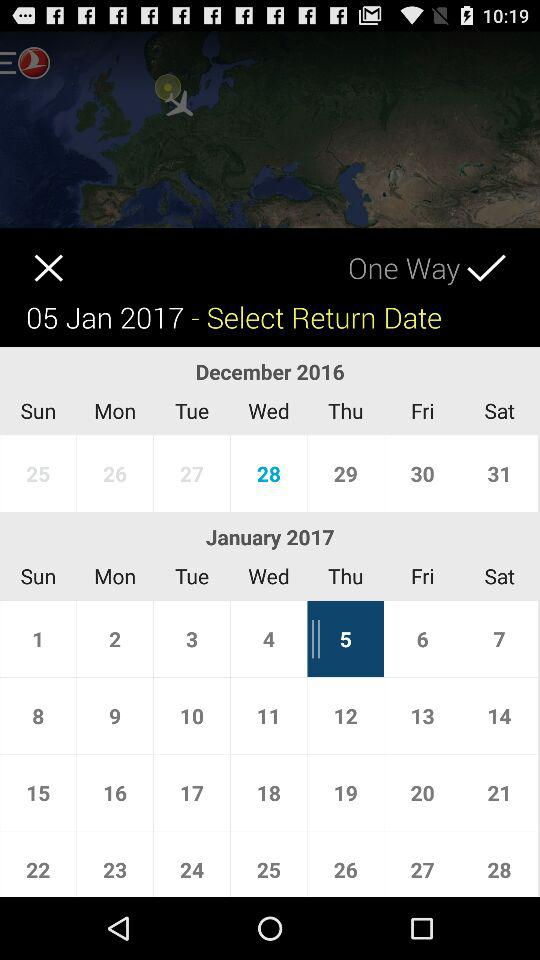Is this one way?
When the provided information is insufficient, respond with <no answer>. <no answer> 